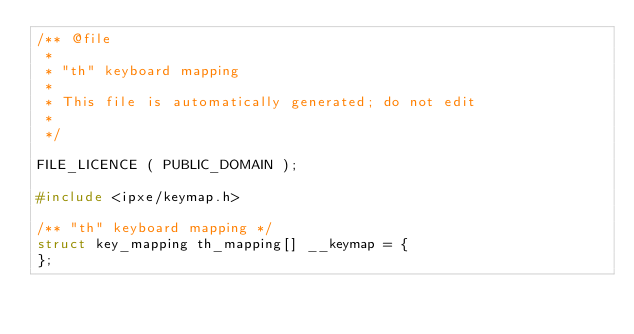Convert code to text. <code><loc_0><loc_0><loc_500><loc_500><_C_>/** @file
 *
 * "th" keyboard mapping
 *
 * This file is automatically generated; do not edit
 *
 */

FILE_LICENCE ( PUBLIC_DOMAIN );

#include <ipxe/keymap.h>

/** "th" keyboard mapping */
struct key_mapping th_mapping[] __keymap = {
};
</code> 